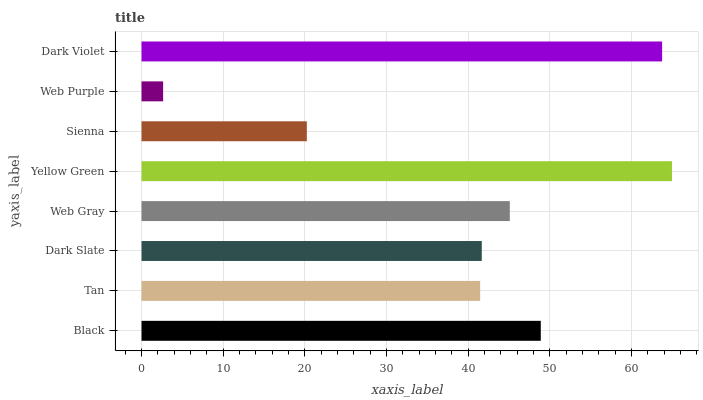Is Web Purple the minimum?
Answer yes or no. Yes. Is Yellow Green the maximum?
Answer yes or no. Yes. Is Tan the minimum?
Answer yes or no. No. Is Tan the maximum?
Answer yes or no. No. Is Black greater than Tan?
Answer yes or no. Yes. Is Tan less than Black?
Answer yes or no. Yes. Is Tan greater than Black?
Answer yes or no. No. Is Black less than Tan?
Answer yes or no. No. Is Web Gray the high median?
Answer yes or no. Yes. Is Dark Slate the low median?
Answer yes or no. Yes. Is Tan the high median?
Answer yes or no. No. Is Sienna the low median?
Answer yes or no. No. 